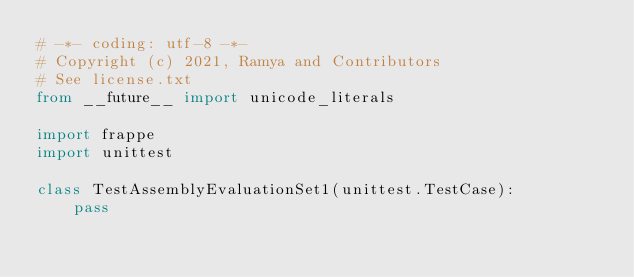<code> <loc_0><loc_0><loc_500><loc_500><_Python_># -*- coding: utf-8 -*-
# Copyright (c) 2021, Ramya and Contributors
# See license.txt
from __future__ import unicode_literals

import frappe
import unittest

class TestAssemblyEvaluationSet1(unittest.TestCase):
	pass
</code> 